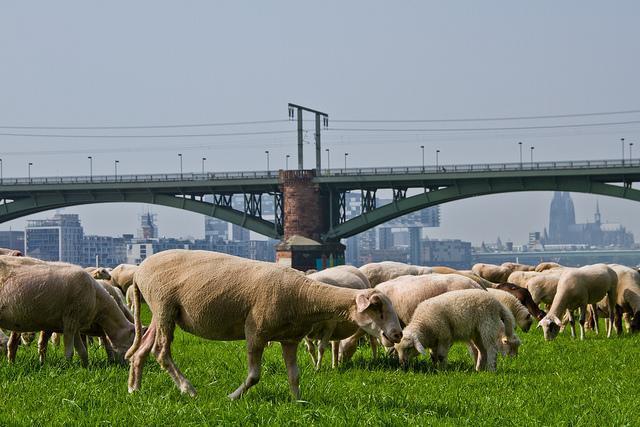How many sheep are in the picture?
Give a very brief answer. 7. How many people in this picture have red hair?
Give a very brief answer. 0. 